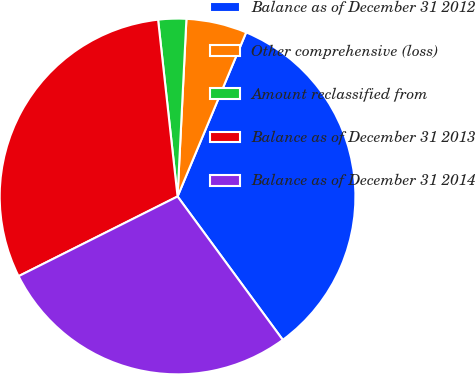Convert chart to OTSL. <chart><loc_0><loc_0><loc_500><loc_500><pie_chart><fcel>Balance as of December 31 2012<fcel>Other comprehensive (loss)<fcel>Amount reclassified from<fcel>Balance as of December 31 2013<fcel>Balance as of December 31 2014<nl><fcel>33.62%<fcel>5.51%<fcel>2.54%<fcel>30.65%<fcel>27.68%<nl></chart> 